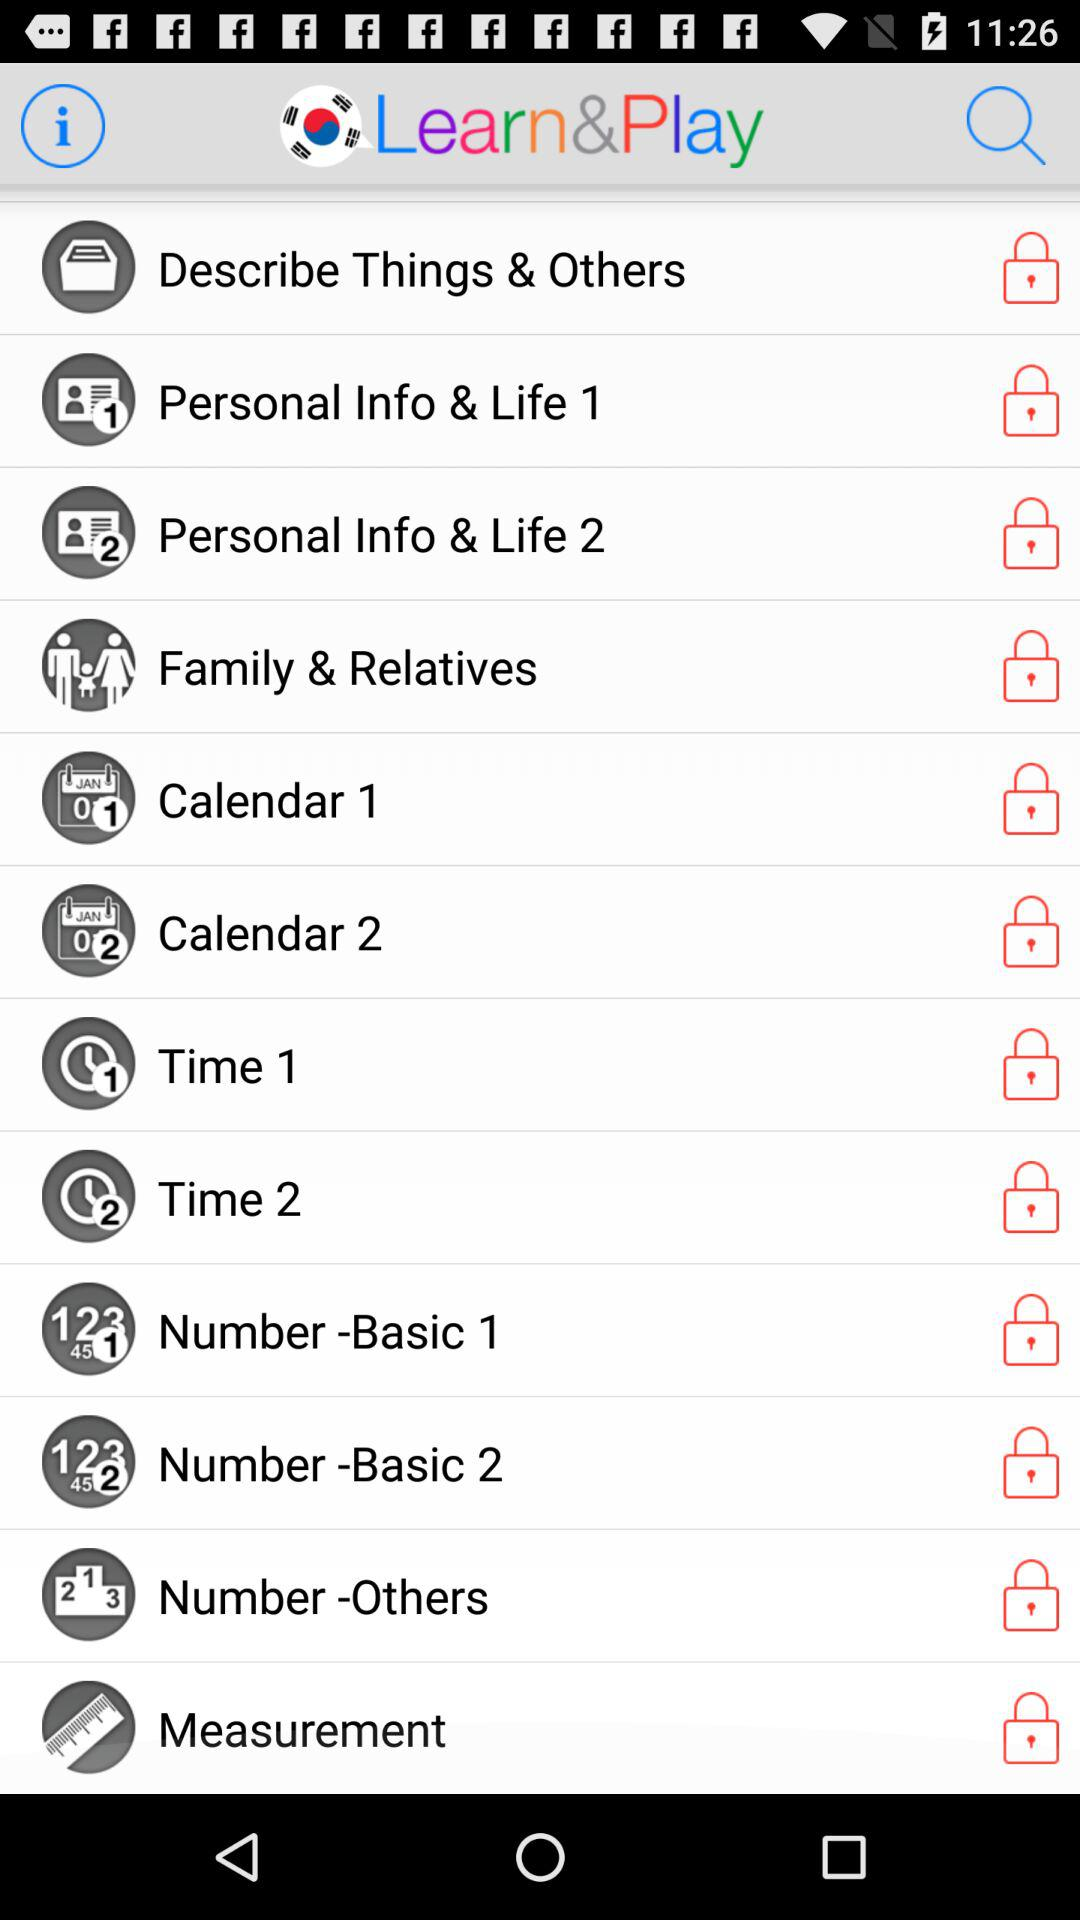What is the app name? The app name is "Learn&Play". 